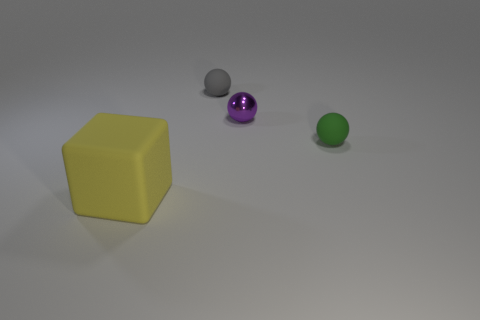Is there any other thing that has the same size as the rubber cube?
Ensure brevity in your answer.  No. There is a thing that is behind the small green object and left of the purple ball; how big is it?
Your response must be concise. Small. How many other things are there of the same material as the large yellow object?
Offer a very short reply. 2. There is a matte sphere behind the purple thing; what is its size?
Provide a short and direct response. Small. Is the color of the cube the same as the metallic object?
Your response must be concise. No. What number of tiny objects are either green shiny cylinders or gray rubber balls?
Provide a succinct answer. 1. Is there anything else of the same color as the tiny metallic ball?
Offer a terse response. No. There is a green matte sphere; are there any tiny rubber objects on the right side of it?
Keep it short and to the point. No. How big is the rubber sphere in front of the tiny rubber sphere left of the green matte object?
Provide a short and direct response. Small. Are there the same number of large yellow cubes that are on the right side of the small green thing and big yellow objects that are behind the purple object?
Give a very brief answer. Yes. 